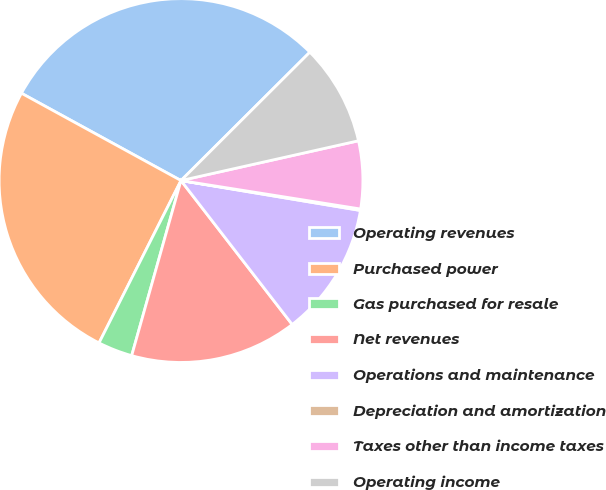<chart> <loc_0><loc_0><loc_500><loc_500><pie_chart><fcel>Operating revenues<fcel>Purchased power<fcel>Gas purchased for resale<fcel>Net revenues<fcel>Operations and maintenance<fcel>Depreciation and amortization<fcel>Taxes other than income taxes<fcel>Operating income<nl><fcel>29.56%<fcel>25.53%<fcel>3.07%<fcel>14.84%<fcel>11.9%<fcel>0.13%<fcel>6.01%<fcel>8.96%<nl></chart> 